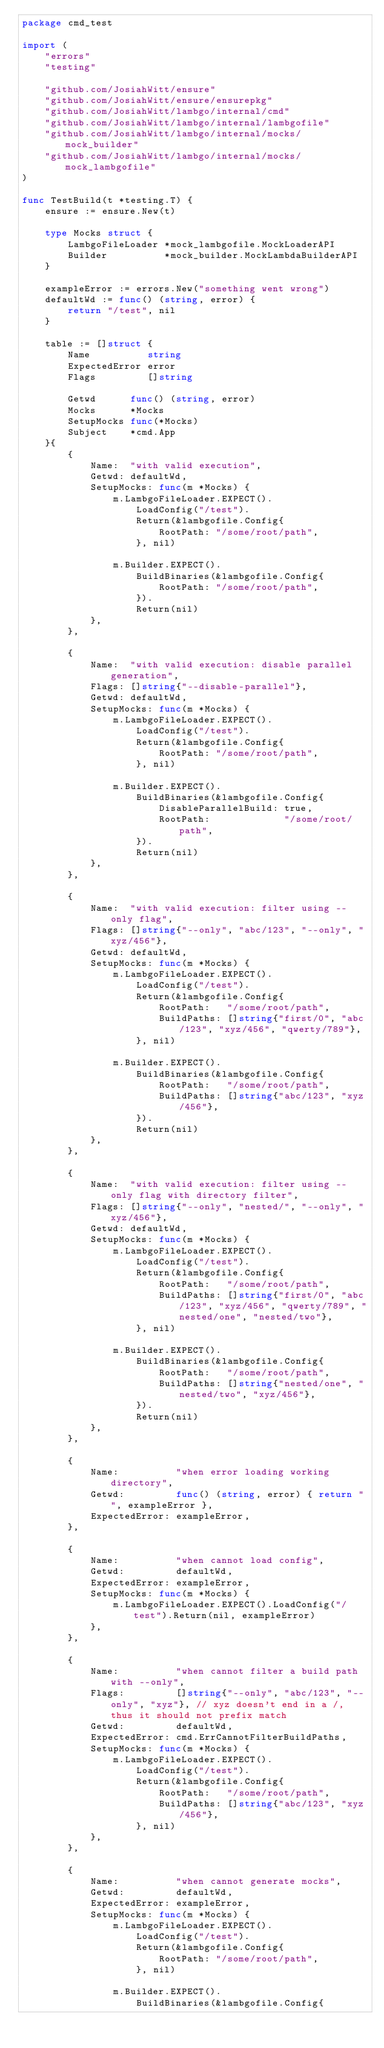Convert code to text. <code><loc_0><loc_0><loc_500><loc_500><_Go_>package cmd_test

import (
	"errors"
	"testing"

	"github.com/JosiahWitt/ensure"
	"github.com/JosiahWitt/ensure/ensurepkg"
	"github.com/JosiahWitt/lambgo/internal/cmd"
	"github.com/JosiahWitt/lambgo/internal/lambgofile"
	"github.com/JosiahWitt/lambgo/internal/mocks/mock_builder"
	"github.com/JosiahWitt/lambgo/internal/mocks/mock_lambgofile"
)

func TestBuild(t *testing.T) {
	ensure := ensure.New(t)

	type Mocks struct {
		LambgoFileLoader *mock_lambgofile.MockLoaderAPI
		Builder          *mock_builder.MockLambdaBuilderAPI
	}

	exampleError := errors.New("something went wrong")
	defaultWd := func() (string, error) {
		return "/test", nil
	}

	table := []struct {
		Name          string
		ExpectedError error
		Flags         []string

		Getwd      func() (string, error)
		Mocks      *Mocks
		SetupMocks func(*Mocks)
		Subject    *cmd.App
	}{
		{
			Name:  "with valid execution",
			Getwd: defaultWd,
			SetupMocks: func(m *Mocks) {
				m.LambgoFileLoader.EXPECT().
					LoadConfig("/test").
					Return(&lambgofile.Config{
						RootPath: "/some/root/path",
					}, nil)

				m.Builder.EXPECT().
					BuildBinaries(&lambgofile.Config{
						RootPath: "/some/root/path",
					}).
					Return(nil)
			},
		},

		{
			Name:  "with valid execution: disable parallel generation",
			Flags: []string{"--disable-parallel"},
			Getwd: defaultWd,
			SetupMocks: func(m *Mocks) {
				m.LambgoFileLoader.EXPECT().
					LoadConfig("/test").
					Return(&lambgofile.Config{
						RootPath: "/some/root/path",
					}, nil)

				m.Builder.EXPECT().
					BuildBinaries(&lambgofile.Config{
						DisableParallelBuild: true,
						RootPath:             "/some/root/path",
					}).
					Return(nil)
			},
		},

		{
			Name:  "with valid execution: filter using --only flag",
			Flags: []string{"--only", "abc/123", "--only", "xyz/456"},
			Getwd: defaultWd,
			SetupMocks: func(m *Mocks) {
				m.LambgoFileLoader.EXPECT().
					LoadConfig("/test").
					Return(&lambgofile.Config{
						RootPath:   "/some/root/path",
						BuildPaths: []string{"first/0", "abc/123", "xyz/456", "qwerty/789"},
					}, nil)

				m.Builder.EXPECT().
					BuildBinaries(&lambgofile.Config{
						RootPath:   "/some/root/path",
						BuildPaths: []string{"abc/123", "xyz/456"},
					}).
					Return(nil)
			},
		},

		{
			Name:  "with valid execution: filter using --only flag with directory filter",
			Flags: []string{"--only", "nested/", "--only", "xyz/456"},
			Getwd: defaultWd,
			SetupMocks: func(m *Mocks) {
				m.LambgoFileLoader.EXPECT().
					LoadConfig("/test").
					Return(&lambgofile.Config{
						RootPath:   "/some/root/path",
						BuildPaths: []string{"first/0", "abc/123", "xyz/456", "qwerty/789", "nested/one", "nested/two"},
					}, nil)

				m.Builder.EXPECT().
					BuildBinaries(&lambgofile.Config{
						RootPath:   "/some/root/path",
						BuildPaths: []string{"nested/one", "nested/two", "xyz/456"},
					}).
					Return(nil)
			},
		},

		{
			Name:          "when error loading working directory",
			Getwd:         func() (string, error) { return "", exampleError },
			ExpectedError: exampleError,
		},

		{
			Name:          "when cannot load config",
			Getwd:         defaultWd,
			ExpectedError: exampleError,
			SetupMocks: func(m *Mocks) {
				m.LambgoFileLoader.EXPECT().LoadConfig("/test").Return(nil, exampleError)
			},
		},

		{
			Name:          "when cannot filter a build path with --only",
			Flags:         []string{"--only", "abc/123", "--only", "xyz"}, // xyz doesn't end in a /, thus it should not prefix match
			Getwd:         defaultWd,
			ExpectedError: cmd.ErrCannotFilterBuildPaths,
			SetupMocks: func(m *Mocks) {
				m.LambgoFileLoader.EXPECT().
					LoadConfig("/test").
					Return(&lambgofile.Config{
						RootPath:   "/some/root/path",
						BuildPaths: []string{"abc/123", "xyz/456"},
					}, nil)
			},
		},

		{
			Name:          "when cannot generate mocks",
			Getwd:         defaultWd,
			ExpectedError: exampleError,
			SetupMocks: func(m *Mocks) {
				m.LambgoFileLoader.EXPECT().
					LoadConfig("/test").
					Return(&lambgofile.Config{
						RootPath: "/some/root/path",
					}, nil)

				m.Builder.EXPECT().
					BuildBinaries(&lambgofile.Config{</code> 